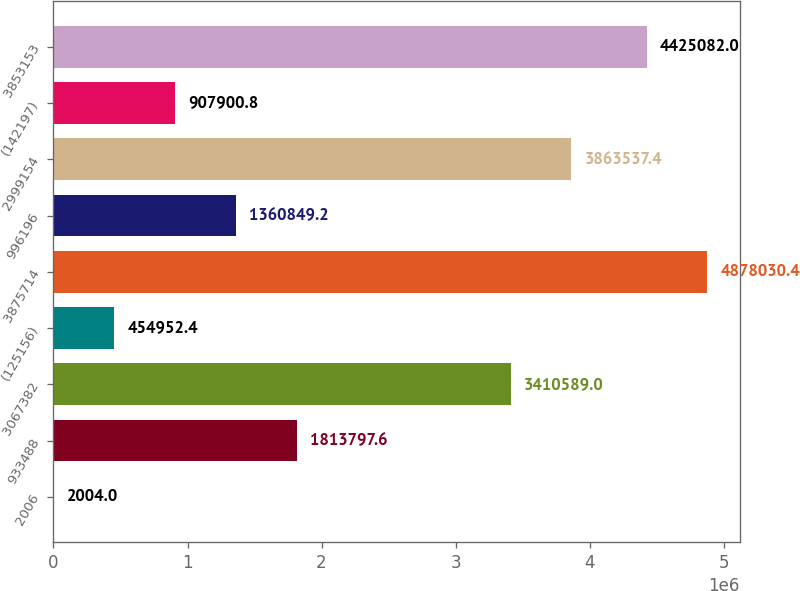Convert chart to OTSL. <chart><loc_0><loc_0><loc_500><loc_500><bar_chart><fcel>2006<fcel>933488<fcel>3067382<fcel>(125156)<fcel>3875714<fcel>996196<fcel>2999154<fcel>(142197)<fcel>3853153<nl><fcel>2004<fcel>1.8138e+06<fcel>3.41059e+06<fcel>454952<fcel>4.87803e+06<fcel>1.36085e+06<fcel>3.86354e+06<fcel>907901<fcel>4.42508e+06<nl></chart> 